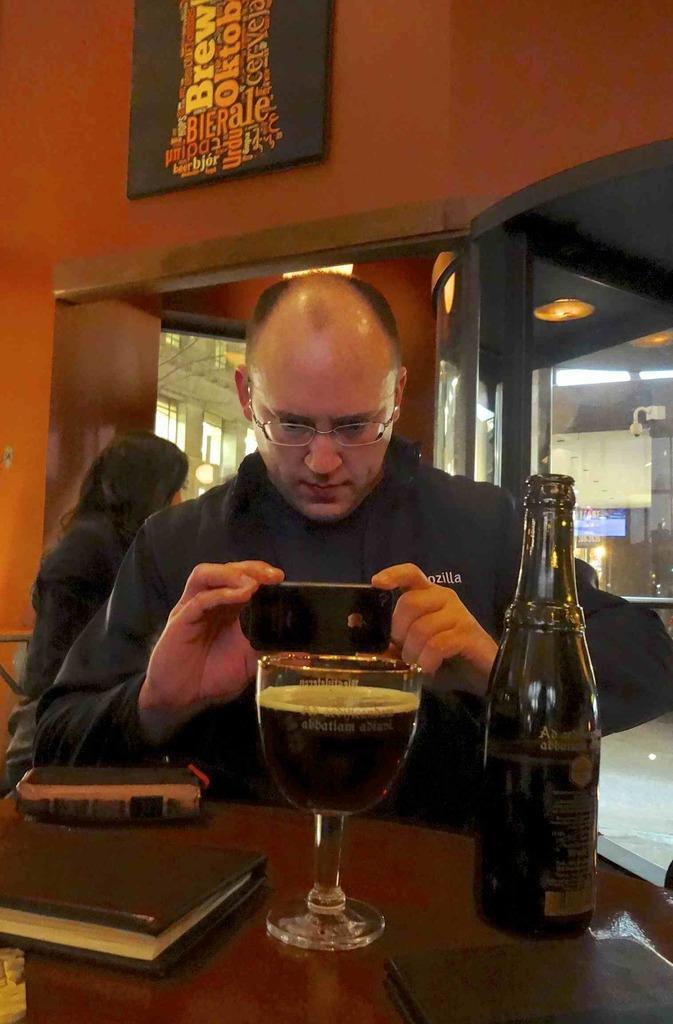Can you describe this image briefly? In this image we have a man who is sitting on a chair in front of the table. He is holding a camera in his hands and taking a picture of a glass. Beside the glass we have glass bottle and on the table we have a book and other stuff on it. Behind the man we have a woman and a wall of red colour. 